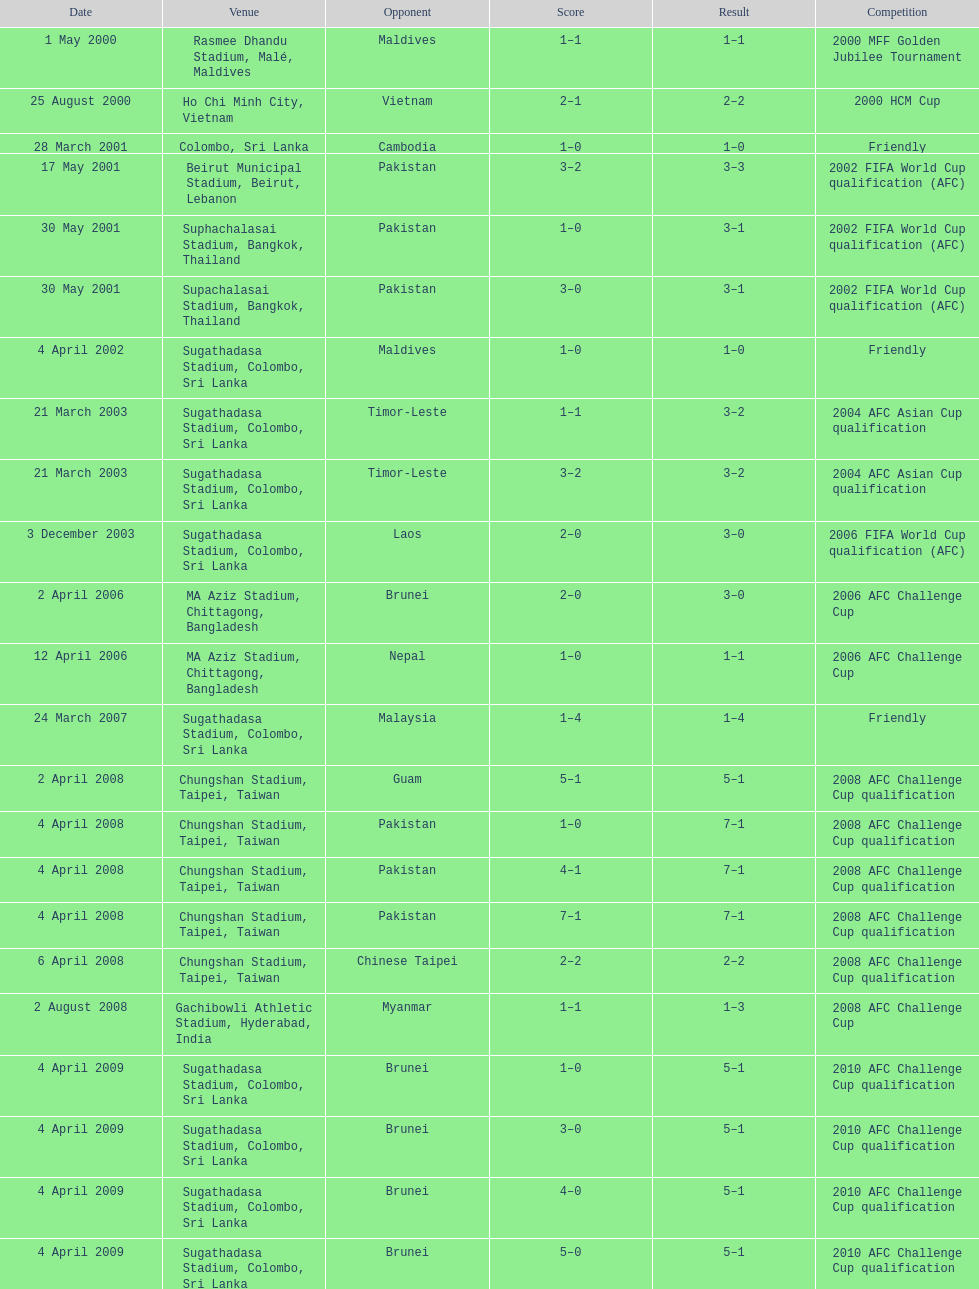What is the highest-ranked venue in the chart? Rasmee Dhandu Stadium, Malé, Maldives. 